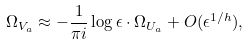Convert formula to latex. <formula><loc_0><loc_0><loc_500><loc_500>\Omega _ { V _ { a } } \approx - \frac { 1 } { \pi i } \log \epsilon \cdot \Omega _ { U _ { a } } + O ( \epsilon ^ { 1 / h } ) ,</formula> 